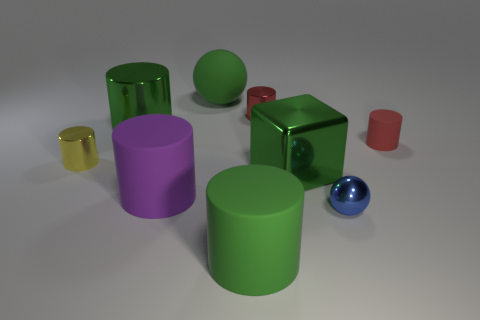What number of other things are the same color as the big metallic cylinder?
Your response must be concise. 3. How many cubes are red matte things or small red things?
Offer a very short reply. 0. What shape is the small yellow shiny object?
Offer a very short reply. Cylinder. There is a small blue thing; are there any matte spheres on the left side of it?
Your response must be concise. Yes. Does the small yellow thing have the same material as the sphere behind the tiny yellow metallic cylinder?
Ensure brevity in your answer.  No. There is a green shiny thing that is behind the yellow shiny cylinder; is it the same shape as the red matte thing?
Offer a very short reply. Yes. How many other large purple cylinders are the same material as the purple cylinder?
Your answer should be very brief. 0. How many objects are either rubber things behind the yellow object or metallic cylinders?
Your answer should be very brief. 5. The yellow metal cylinder has what size?
Ensure brevity in your answer.  Small. What is the material of the large green block that is in front of the tiny metal cylinder left of the red metallic cylinder?
Provide a succinct answer. Metal. 